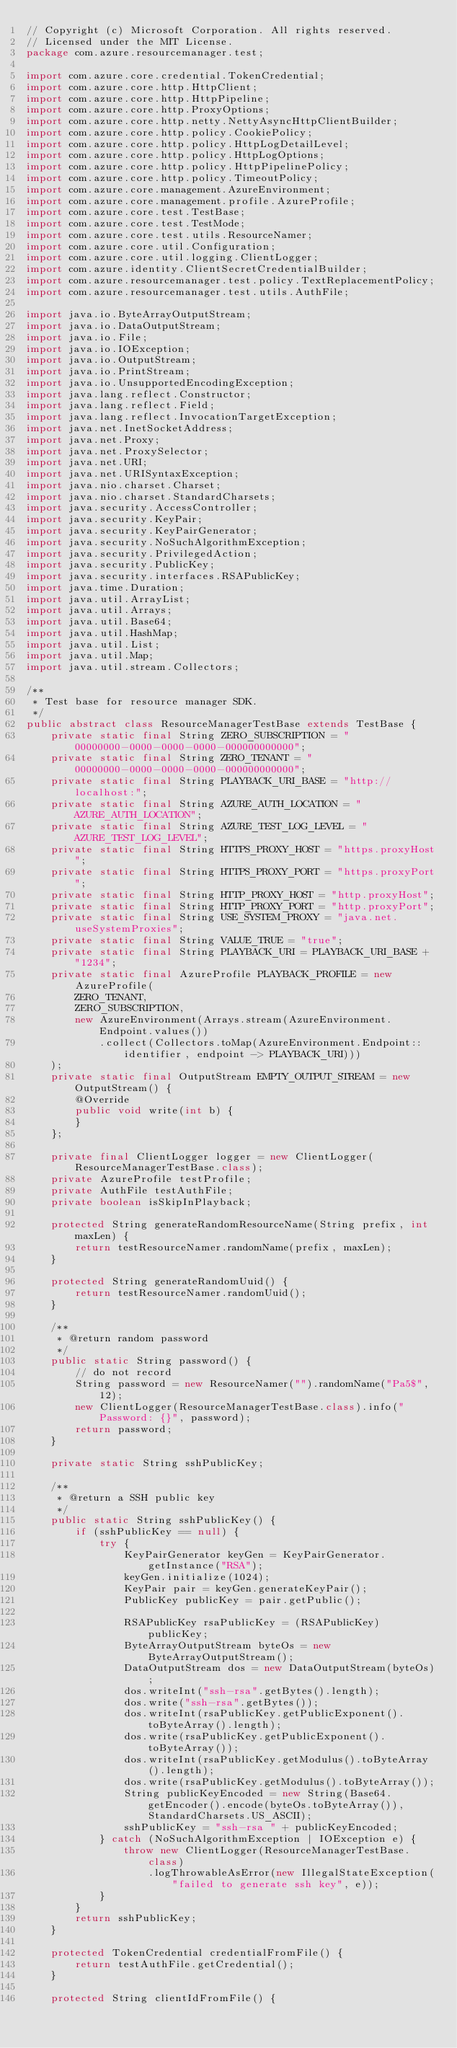Convert code to text. <code><loc_0><loc_0><loc_500><loc_500><_Java_>// Copyright (c) Microsoft Corporation. All rights reserved.
// Licensed under the MIT License.
package com.azure.resourcemanager.test;

import com.azure.core.credential.TokenCredential;
import com.azure.core.http.HttpClient;
import com.azure.core.http.HttpPipeline;
import com.azure.core.http.ProxyOptions;
import com.azure.core.http.netty.NettyAsyncHttpClientBuilder;
import com.azure.core.http.policy.CookiePolicy;
import com.azure.core.http.policy.HttpLogDetailLevel;
import com.azure.core.http.policy.HttpLogOptions;
import com.azure.core.http.policy.HttpPipelinePolicy;
import com.azure.core.http.policy.TimeoutPolicy;
import com.azure.core.management.AzureEnvironment;
import com.azure.core.management.profile.AzureProfile;
import com.azure.core.test.TestBase;
import com.azure.core.test.TestMode;
import com.azure.core.test.utils.ResourceNamer;
import com.azure.core.util.Configuration;
import com.azure.core.util.logging.ClientLogger;
import com.azure.identity.ClientSecretCredentialBuilder;
import com.azure.resourcemanager.test.policy.TextReplacementPolicy;
import com.azure.resourcemanager.test.utils.AuthFile;

import java.io.ByteArrayOutputStream;
import java.io.DataOutputStream;
import java.io.File;
import java.io.IOException;
import java.io.OutputStream;
import java.io.PrintStream;
import java.io.UnsupportedEncodingException;
import java.lang.reflect.Constructor;
import java.lang.reflect.Field;
import java.lang.reflect.InvocationTargetException;
import java.net.InetSocketAddress;
import java.net.Proxy;
import java.net.ProxySelector;
import java.net.URI;
import java.net.URISyntaxException;
import java.nio.charset.Charset;
import java.nio.charset.StandardCharsets;
import java.security.AccessController;
import java.security.KeyPair;
import java.security.KeyPairGenerator;
import java.security.NoSuchAlgorithmException;
import java.security.PrivilegedAction;
import java.security.PublicKey;
import java.security.interfaces.RSAPublicKey;
import java.time.Duration;
import java.util.ArrayList;
import java.util.Arrays;
import java.util.Base64;
import java.util.HashMap;
import java.util.List;
import java.util.Map;
import java.util.stream.Collectors;

/**
 * Test base for resource manager SDK.
 */
public abstract class ResourceManagerTestBase extends TestBase {
    private static final String ZERO_SUBSCRIPTION = "00000000-0000-0000-0000-000000000000";
    private static final String ZERO_TENANT = "00000000-0000-0000-0000-000000000000";
    private static final String PLAYBACK_URI_BASE = "http://localhost:";
    private static final String AZURE_AUTH_LOCATION = "AZURE_AUTH_LOCATION";
    private static final String AZURE_TEST_LOG_LEVEL = "AZURE_TEST_LOG_LEVEL";
    private static final String HTTPS_PROXY_HOST = "https.proxyHost";
    private static final String HTTPS_PROXY_PORT = "https.proxyPort";
    private static final String HTTP_PROXY_HOST = "http.proxyHost";
    private static final String HTTP_PROXY_PORT = "http.proxyPort";
    private static final String USE_SYSTEM_PROXY = "java.net.useSystemProxies";
    private static final String VALUE_TRUE = "true";
    private static final String PLAYBACK_URI = PLAYBACK_URI_BASE + "1234";
    private static final AzureProfile PLAYBACK_PROFILE = new AzureProfile(
        ZERO_TENANT,
        ZERO_SUBSCRIPTION,
        new AzureEnvironment(Arrays.stream(AzureEnvironment.Endpoint.values())
            .collect(Collectors.toMap(AzureEnvironment.Endpoint::identifier, endpoint -> PLAYBACK_URI)))
    );
    private static final OutputStream EMPTY_OUTPUT_STREAM = new OutputStream() {
        @Override
        public void write(int b) {
        }
    };

    private final ClientLogger logger = new ClientLogger(ResourceManagerTestBase.class);
    private AzureProfile testProfile;
    private AuthFile testAuthFile;
    private boolean isSkipInPlayback;

    protected String generateRandomResourceName(String prefix, int maxLen) {
        return testResourceNamer.randomName(prefix, maxLen);
    }

    protected String generateRandomUuid() {
        return testResourceNamer.randomUuid();
    }

    /**
     * @return random password
     */
    public static String password() {
        // do not record
        String password = new ResourceNamer("").randomName("Pa5$", 12);
        new ClientLogger(ResourceManagerTestBase.class).info("Password: {}", password);
        return password;
    }

    private static String sshPublicKey;

    /**
     * @return a SSH public key
     */
    public static String sshPublicKey() {
        if (sshPublicKey == null) {
            try {
                KeyPairGenerator keyGen = KeyPairGenerator.getInstance("RSA");
                keyGen.initialize(1024);
                KeyPair pair = keyGen.generateKeyPair();
                PublicKey publicKey = pair.getPublic();

                RSAPublicKey rsaPublicKey = (RSAPublicKey) publicKey;
                ByteArrayOutputStream byteOs = new ByteArrayOutputStream();
                DataOutputStream dos = new DataOutputStream(byteOs);
                dos.writeInt("ssh-rsa".getBytes().length);
                dos.write("ssh-rsa".getBytes());
                dos.writeInt(rsaPublicKey.getPublicExponent().toByteArray().length);
                dos.write(rsaPublicKey.getPublicExponent().toByteArray());
                dos.writeInt(rsaPublicKey.getModulus().toByteArray().length);
                dos.write(rsaPublicKey.getModulus().toByteArray());
                String publicKeyEncoded = new String(Base64.getEncoder().encode(byteOs.toByteArray()), StandardCharsets.US_ASCII);
                sshPublicKey = "ssh-rsa " + publicKeyEncoded;
            } catch (NoSuchAlgorithmException | IOException e) {
                throw new ClientLogger(ResourceManagerTestBase.class)
                    .logThrowableAsError(new IllegalStateException("failed to generate ssh key", e));
            }
        }
        return sshPublicKey;
    }

    protected TokenCredential credentialFromFile() {
        return testAuthFile.getCredential();
    }

    protected String clientIdFromFile() {</code> 